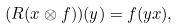<formula> <loc_0><loc_0><loc_500><loc_500>( R ( x \otimes f ) ) ( y ) = f ( y x ) ,</formula> 